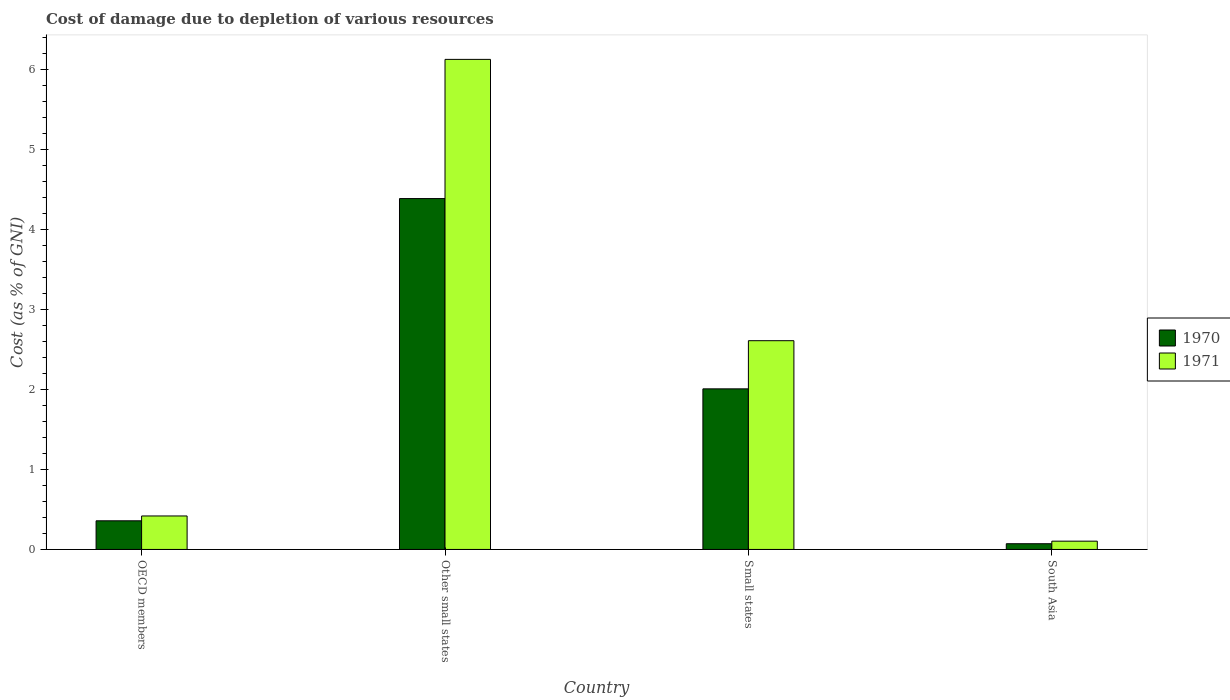Are the number of bars per tick equal to the number of legend labels?
Keep it short and to the point. Yes. Are the number of bars on each tick of the X-axis equal?
Your answer should be compact. Yes. How many bars are there on the 1st tick from the left?
Keep it short and to the point. 2. How many bars are there on the 2nd tick from the right?
Offer a very short reply. 2. What is the label of the 2nd group of bars from the left?
Provide a short and direct response. Other small states. In how many cases, is the number of bars for a given country not equal to the number of legend labels?
Provide a succinct answer. 0. What is the cost of damage caused due to the depletion of various resources in 1970 in Small states?
Provide a succinct answer. 2.01. Across all countries, what is the maximum cost of damage caused due to the depletion of various resources in 1971?
Provide a short and direct response. 6.13. Across all countries, what is the minimum cost of damage caused due to the depletion of various resources in 1971?
Keep it short and to the point. 0.1. In which country was the cost of damage caused due to the depletion of various resources in 1971 maximum?
Offer a terse response. Other small states. What is the total cost of damage caused due to the depletion of various resources in 1971 in the graph?
Keep it short and to the point. 9.26. What is the difference between the cost of damage caused due to the depletion of various resources in 1970 in OECD members and that in South Asia?
Provide a succinct answer. 0.29. What is the difference between the cost of damage caused due to the depletion of various resources in 1970 in OECD members and the cost of damage caused due to the depletion of various resources in 1971 in Small states?
Provide a succinct answer. -2.25. What is the average cost of damage caused due to the depletion of various resources in 1970 per country?
Provide a succinct answer. 1.71. What is the difference between the cost of damage caused due to the depletion of various resources of/in 1971 and cost of damage caused due to the depletion of various resources of/in 1970 in OECD members?
Offer a very short reply. 0.06. What is the ratio of the cost of damage caused due to the depletion of various resources in 1971 in OECD members to that in South Asia?
Keep it short and to the point. 4.04. What is the difference between the highest and the second highest cost of damage caused due to the depletion of various resources in 1970?
Offer a very short reply. -1.65. What is the difference between the highest and the lowest cost of damage caused due to the depletion of various resources in 1970?
Make the answer very short. 4.31. What does the 2nd bar from the left in Other small states represents?
Your response must be concise. 1971. What does the 1st bar from the right in South Asia represents?
Ensure brevity in your answer.  1971. Does the graph contain any zero values?
Give a very brief answer. No. Where does the legend appear in the graph?
Keep it short and to the point. Center right. How many legend labels are there?
Make the answer very short. 2. How are the legend labels stacked?
Your answer should be very brief. Vertical. What is the title of the graph?
Provide a short and direct response. Cost of damage due to depletion of various resources. Does "1994" appear as one of the legend labels in the graph?
Offer a terse response. No. What is the label or title of the Y-axis?
Offer a terse response. Cost (as % of GNI). What is the Cost (as % of GNI) in 1970 in OECD members?
Your answer should be very brief. 0.36. What is the Cost (as % of GNI) of 1971 in OECD members?
Your response must be concise. 0.42. What is the Cost (as % of GNI) of 1970 in Other small states?
Your answer should be very brief. 4.39. What is the Cost (as % of GNI) of 1971 in Other small states?
Keep it short and to the point. 6.13. What is the Cost (as % of GNI) in 1970 in Small states?
Your answer should be very brief. 2.01. What is the Cost (as % of GNI) of 1971 in Small states?
Make the answer very short. 2.61. What is the Cost (as % of GNI) in 1970 in South Asia?
Make the answer very short. 0.07. What is the Cost (as % of GNI) of 1971 in South Asia?
Offer a terse response. 0.1. Across all countries, what is the maximum Cost (as % of GNI) in 1970?
Provide a short and direct response. 4.39. Across all countries, what is the maximum Cost (as % of GNI) in 1971?
Give a very brief answer. 6.13. Across all countries, what is the minimum Cost (as % of GNI) of 1970?
Your answer should be compact. 0.07. Across all countries, what is the minimum Cost (as % of GNI) of 1971?
Ensure brevity in your answer.  0.1. What is the total Cost (as % of GNI) in 1970 in the graph?
Provide a short and direct response. 6.82. What is the total Cost (as % of GNI) of 1971 in the graph?
Your response must be concise. 9.26. What is the difference between the Cost (as % of GNI) in 1970 in OECD members and that in Other small states?
Offer a very short reply. -4.03. What is the difference between the Cost (as % of GNI) of 1971 in OECD members and that in Other small states?
Provide a succinct answer. -5.71. What is the difference between the Cost (as % of GNI) of 1970 in OECD members and that in Small states?
Offer a very short reply. -1.65. What is the difference between the Cost (as % of GNI) in 1971 in OECD members and that in Small states?
Your answer should be very brief. -2.19. What is the difference between the Cost (as % of GNI) in 1970 in OECD members and that in South Asia?
Offer a very short reply. 0.29. What is the difference between the Cost (as % of GNI) in 1971 in OECD members and that in South Asia?
Provide a short and direct response. 0.31. What is the difference between the Cost (as % of GNI) in 1970 in Other small states and that in Small states?
Your answer should be very brief. 2.38. What is the difference between the Cost (as % of GNI) of 1971 in Other small states and that in Small states?
Your response must be concise. 3.52. What is the difference between the Cost (as % of GNI) of 1970 in Other small states and that in South Asia?
Your answer should be compact. 4.31. What is the difference between the Cost (as % of GNI) of 1971 in Other small states and that in South Asia?
Your answer should be very brief. 6.02. What is the difference between the Cost (as % of GNI) in 1970 in Small states and that in South Asia?
Offer a terse response. 1.94. What is the difference between the Cost (as % of GNI) in 1971 in Small states and that in South Asia?
Keep it short and to the point. 2.51. What is the difference between the Cost (as % of GNI) of 1970 in OECD members and the Cost (as % of GNI) of 1971 in Other small states?
Offer a terse response. -5.77. What is the difference between the Cost (as % of GNI) in 1970 in OECD members and the Cost (as % of GNI) in 1971 in Small states?
Give a very brief answer. -2.25. What is the difference between the Cost (as % of GNI) of 1970 in OECD members and the Cost (as % of GNI) of 1971 in South Asia?
Keep it short and to the point. 0.25. What is the difference between the Cost (as % of GNI) of 1970 in Other small states and the Cost (as % of GNI) of 1971 in Small states?
Provide a succinct answer. 1.78. What is the difference between the Cost (as % of GNI) in 1970 in Other small states and the Cost (as % of GNI) in 1971 in South Asia?
Provide a succinct answer. 4.28. What is the difference between the Cost (as % of GNI) of 1970 in Small states and the Cost (as % of GNI) of 1971 in South Asia?
Give a very brief answer. 1.9. What is the average Cost (as % of GNI) in 1970 per country?
Ensure brevity in your answer.  1.71. What is the average Cost (as % of GNI) of 1971 per country?
Your answer should be very brief. 2.31. What is the difference between the Cost (as % of GNI) in 1970 and Cost (as % of GNI) in 1971 in OECD members?
Your answer should be compact. -0.06. What is the difference between the Cost (as % of GNI) in 1970 and Cost (as % of GNI) in 1971 in Other small states?
Your response must be concise. -1.74. What is the difference between the Cost (as % of GNI) in 1970 and Cost (as % of GNI) in 1971 in Small states?
Ensure brevity in your answer.  -0.6. What is the difference between the Cost (as % of GNI) in 1970 and Cost (as % of GNI) in 1971 in South Asia?
Offer a terse response. -0.03. What is the ratio of the Cost (as % of GNI) of 1970 in OECD members to that in Other small states?
Offer a terse response. 0.08. What is the ratio of the Cost (as % of GNI) of 1971 in OECD members to that in Other small states?
Give a very brief answer. 0.07. What is the ratio of the Cost (as % of GNI) of 1970 in OECD members to that in Small states?
Offer a very short reply. 0.18. What is the ratio of the Cost (as % of GNI) of 1971 in OECD members to that in Small states?
Make the answer very short. 0.16. What is the ratio of the Cost (as % of GNI) of 1970 in OECD members to that in South Asia?
Provide a short and direct response. 5. What is the ratio of the Cost (as % of GNI) in 1971 in OECD members to that in South Asia?
Provide a short and direct response. 4.04. What is the ratio of the Cost (as % of GNI) of 1970 in Other small states to that in Small states?
Give a very brief answer. 2.18. What is the ratio of the Cost (as % of GNI) in 1971 in Other small states to that in Small states?
Offer a terse response. 2.35. What is the ratio of the Cost (as % of GNI) in 1970 in Other small states to that in South Asia?
Offer a terse response. 61.21. What is the ratio of the Cost (as % of GNI) in 1971 in Other small states to that in South Asia?
Give a very brief answer. 59.08. What is the ratio of the Cost (as % of GNI) of 1970 in Small states to that in South Asia?
Provide a succinct answer. 28.02. What is the ratio of the Cost (as % of GNI) in 1971 in Small states to that in South Asia?
Give a very brief answer. 25.17. What is the difference between the highest and the second highest Cost (as % of GNI) of 1970?
Your answer should be very brief. 2.38. What is the difference between the highest and the second highest Cost (as % of GNI) of 1971?
Your answer should be compact. 3.52. What is the difference between the highest and the lowest Cost (as % of GNI) in 1970?
Keep it short and to the point. 4.31. What is the difference between the highest and the lowest Cost (as % of GNI) in 1971?
Ensure brevity in your answer.  6.02. 